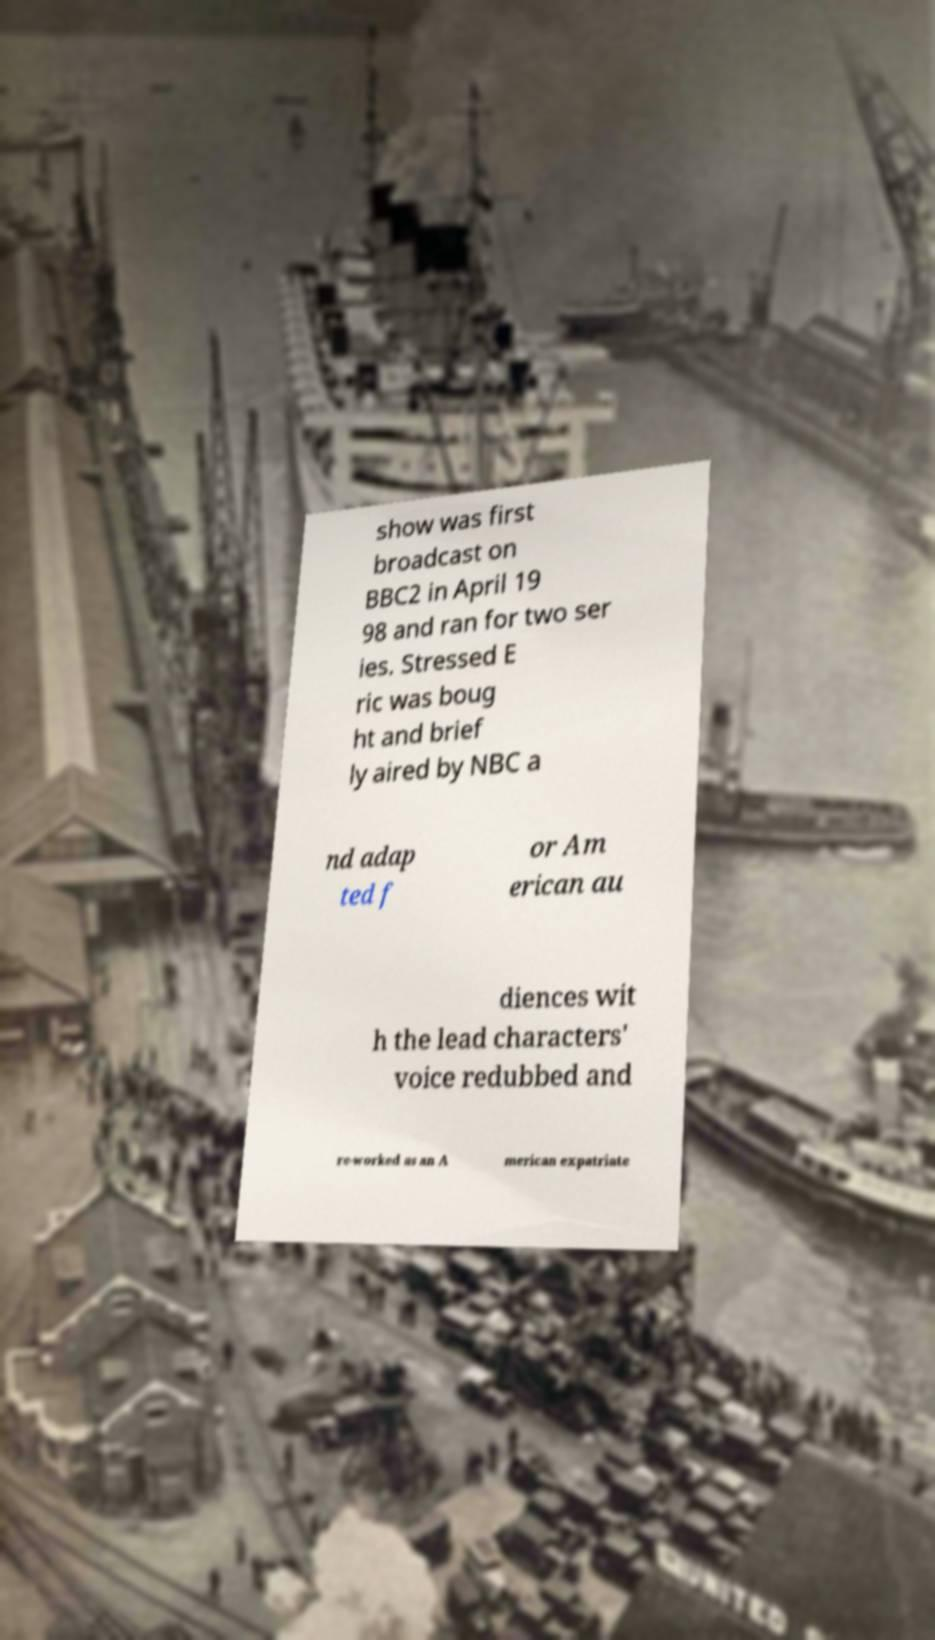I need the written content from this picture converted into text. Can you do that? show was first broadcast on BBC2 in April 19 98 and ran for two ser ies. Stressed E ric was boug ht and brief ly aired by NBC a nd adap ted f or Am erican au diences wit h the lead characters' voice redubbed and re-worked as an A merican expatriate 